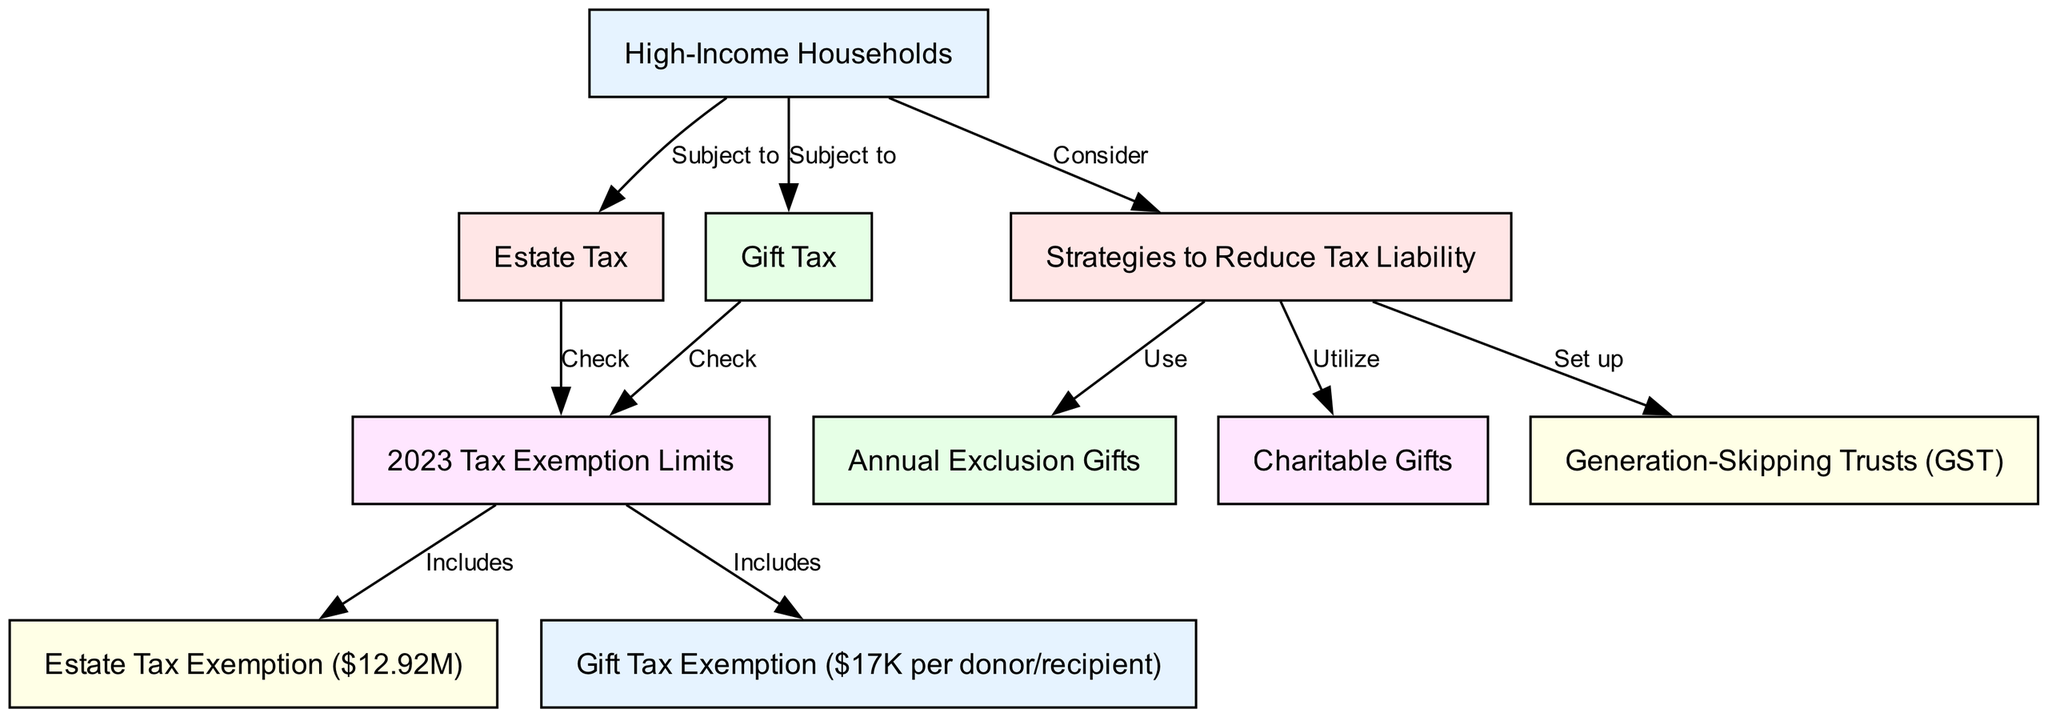What is the estate tax exemption for high-income households in 2023? The diagram indicates that the estate tax exemption for high-income households in 2023 is $12.92 million. This node is directly linked from the "2023 Tax Exemption Limits" node, which lists the estate tax exemption as one of its components.
Answer: $12.92M What is the gift tax exemption per donor/recipient for 2023? The diagram shows that the gift tax exemption per donor/recipient in 2023 is $17,000. This information is derived from the "2023 Tax Exemption Limits" that includes the gift tax exemption.
Answer: $17K How many strategies are suggested for reducing tax liability? The diagram presents three strategies indicated by the nodes connected to the "Strategies to Reduce Tax Liability" node: annual exclusion gifts, charitable gifts, and generation-skipping trusts. The count of these strategies gives the answer.
Answer: 3 What two types of taxes are high-income households subject to? High-income households are subject to estate tax and gift tax, as indicated by the arrows pointing from "High-Income Households" to both "Estate Tax" and "Gift Tax." Each represents a type of tax these households must navigate.
Answer: Estate Tax, Gift Tax Which type of gifts can help reduce tax liability according to the diagram? The diagram suggests utilizing charitable gifts to help reduce tax liability. This is linked to the "Strategies to Reduce Tax Liability" node, which indicates the action of utilizing charitable gifts as a specific method.
Answer: Charitable Gifts What do high-income households consider regarding their tax planning? According to the diagram, high-income households consider "Strategies to Reduce Tax Liability." This is evidenced by the directional arrow pointing from "High-Income Households" to "Strategies to Reduce Tax Liability," indicating a consideration of these strategies in tax planning.
Answer: Strategies to Reduce Tax Liability What is the relationship between estate tax and tax exemption limits? The diagram illustrates that the estate tax is subject to checking tax exemption limits, as indicated by the edge pointing from "Estate Tax" to "2023 Tax Exemption Limits." This signifies the need to reference exemption limits to assess estate tax implications.
Answer: Check What type of trust is mentioned as a strategy in the diagram? The diagram mentions Generation-Skipping Trusts (GST) as one of the strategies to reduce tax liability. This is found in the section detailing the strategies node, reinforcing its relevance to tax planning for high-income households.
Answer: Generation-Skipping Trusts (GST) 